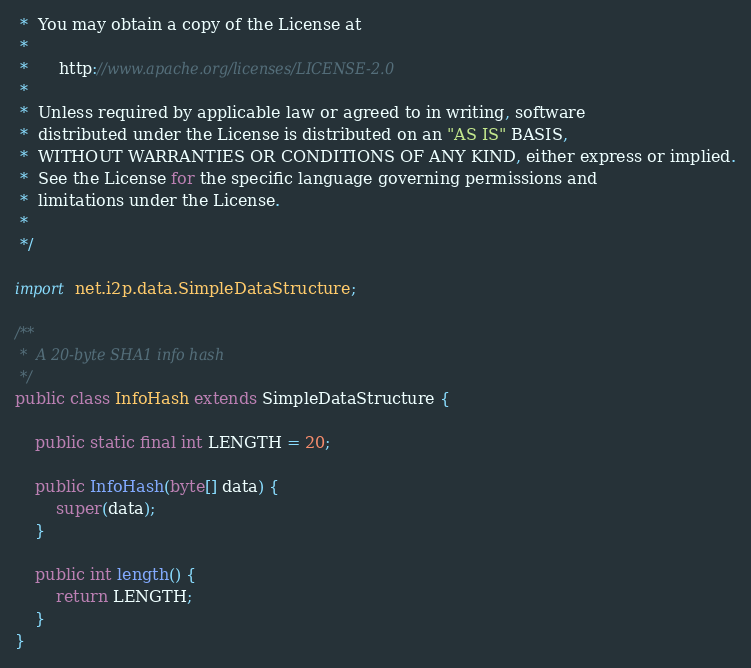<code> <loc_0><loc_0><loc_500><loc_500><_Java_> *  You may obtain a copy of the License at
 *
 *      http://www.apache.org/licenses/LICENSE-2.0
 *
 *  Unless required by applicable law or agreed to in writing, software
 *  distributed under the License is distributed on an "AS IS" BASIS,
 *  WITHOUT WARRANTIES OR CONDITIONS OF ANY KIND, either express or implied.
 *  See the License for the specific language governing permissions and
 *  limitations under the License.
 *
 */

import net.i2p.data.SimpleDataStructure;

/**
 *  A 20-byte SHA1 info hash
 */
public class InfoHash extends SimpleDataStructure {

    public static final int LENGTH = 20;

    public InfoHash(byte[] data) {
        super(data);
    }

    public int length() {
        return LENGTH;
    }
}
</code> 